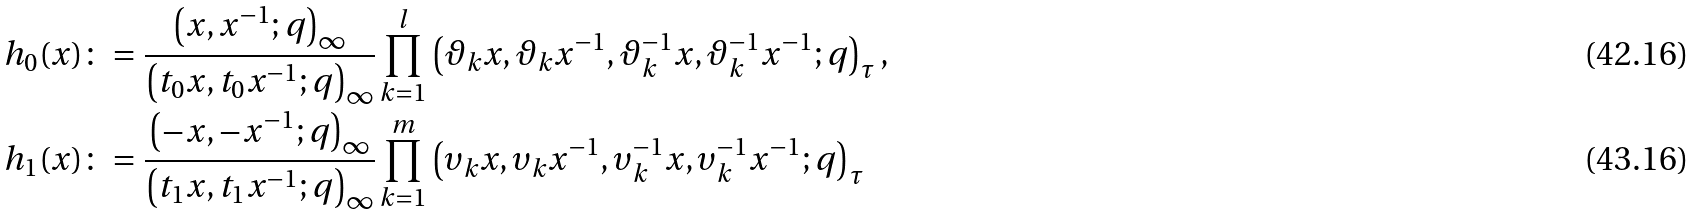<formula> <loc_0><loc_0><loc_500><loc_500>h _ { 0 } ( x ) & \colon = \frac { \left ( x , x ^ { - 1 } ; q \right ) _ { \infty } } { \left ( t _ { 0 } x , t _ { 0 } x ^ { - 1 } ; q \right ) _ { \infty } } \prod _ { k = 1 } ^ { l } \left ( \vartheta _ { k } x , \vartheta _ { k } x ^ { - 1 } , \vartheta _ { k } ^ { - 1 } x , \vartheta _ { k } ^ { - 1 } x ^ { - 1 } ; q \right ) _ { \tau } , \\ h _ { 1 } ( x ) & \colon = \frac { \left ( - x , - x ^ { - 1 } ; q \right ) _ { \infty } } { \left ( t _ { 1 } x , t _ { 1 } x ^ { - 1 } ; q \right ) _ { \infty } } \prod _ { k = 1 } ^ { m } \left ( \upsilon _ { k } x , \upsilon _ { k } x ^ { - 1 } , \upsilon _ { k } ^ { - 1 } x , \upsilon _ { k } ^ { - 1 } x ^ { - 1 } ; q \right ) _ { \tau }</formula> 